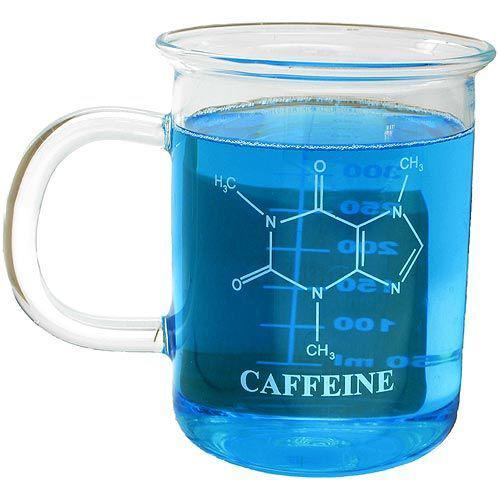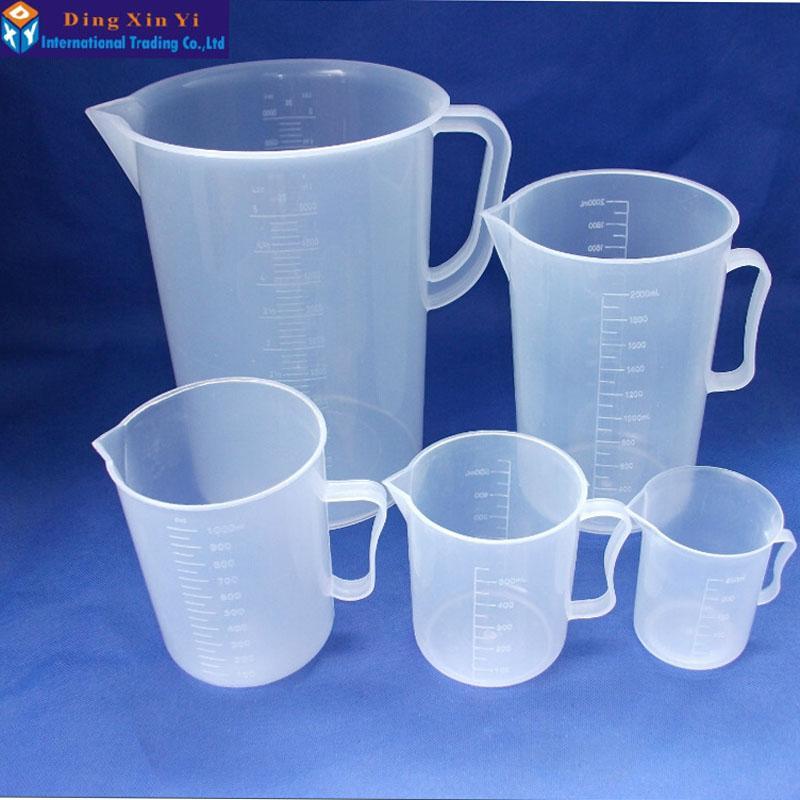The first image is the image on the left, the second image is the image on the right. Examine the images to the left and right. Is the description "The container in each of the images is filled with dark liquid." accurate? Answer yes or no. No. The first image is the image on the left, the second image is the image on the right. Considering the images on both sides, is "Both beakers are full of coffee." valid? Answer yes or no. No. 